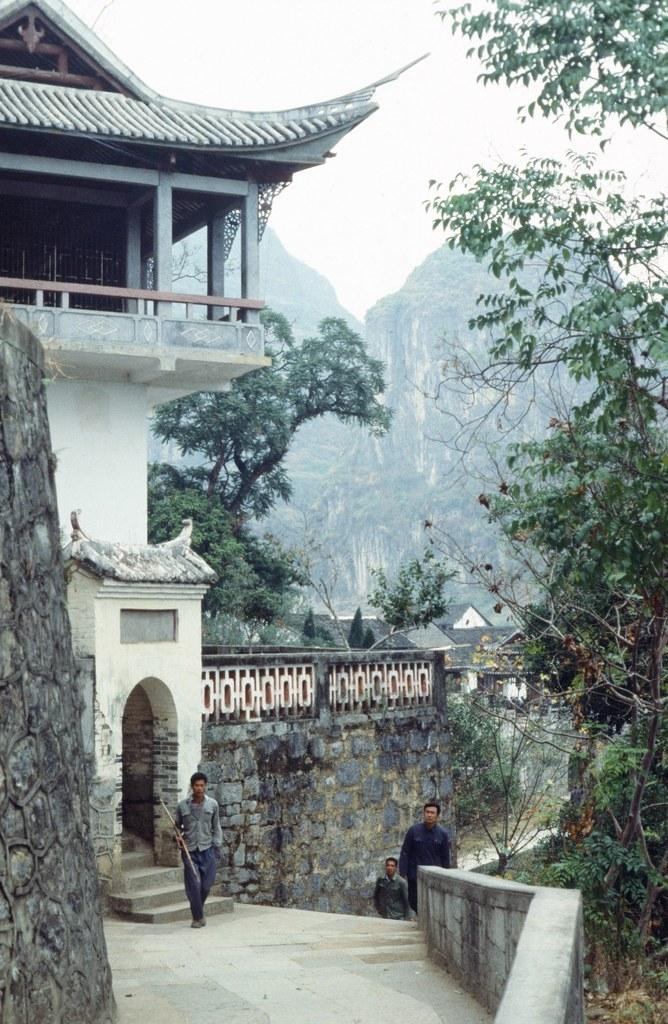What structure is located on the left side of the image? There is a house on the left side of the image. What can be seen in the center of the image? There are people in the center of the image. What type of vegetation is on the right side of the image? There are trees on the right side of the image. Are there any trees on the left side of the image? Yes, there are trees on the left side of the image. What type of invention is being demonstrated by the geese in the image? There are no geese present in the image, and therefore no invention can be demonstrated by them. How many hands are visible in the image? There is no mention of hands in the provided facts, so we cannot determine how many hands are visible in the image. 